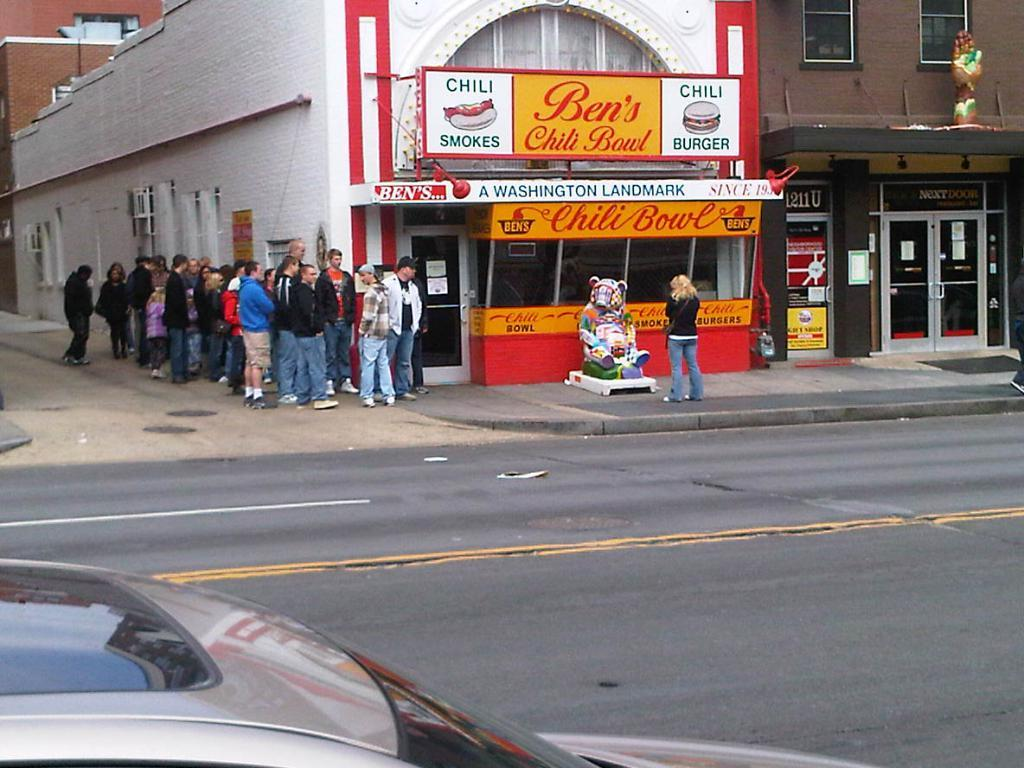<image>
Give a short and clear explanation of the subsequent image. Ben's Chili Bowl written on the sign of a building 